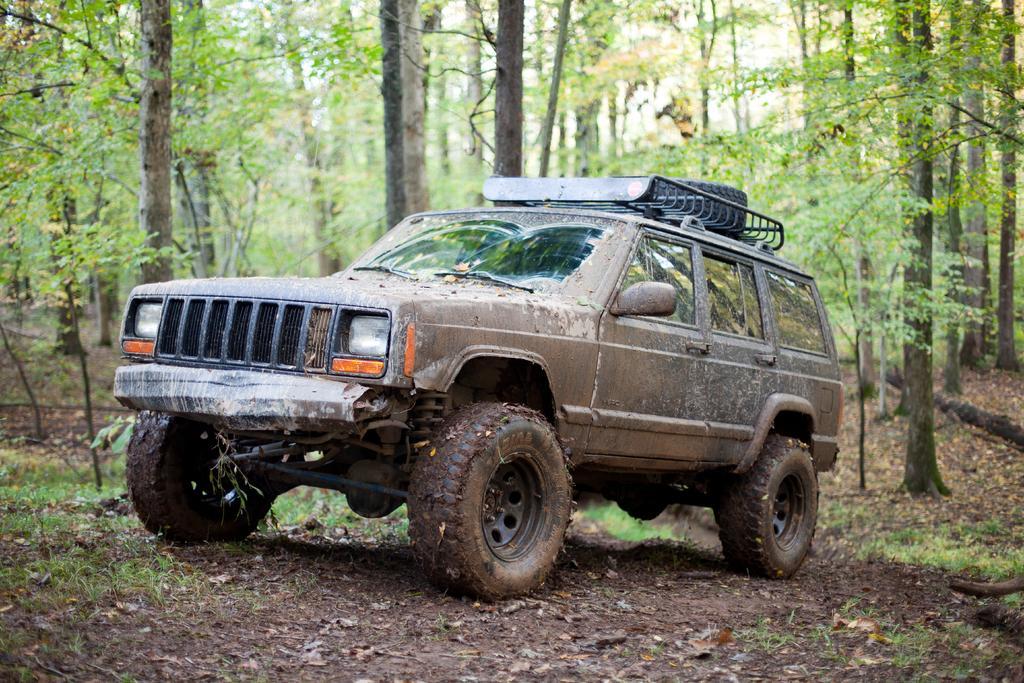Please provide a concise description of this image. In this image I can see a vehicle which is brown, black and orange in color on the ground. I can see the ground, few trees and the sky. 